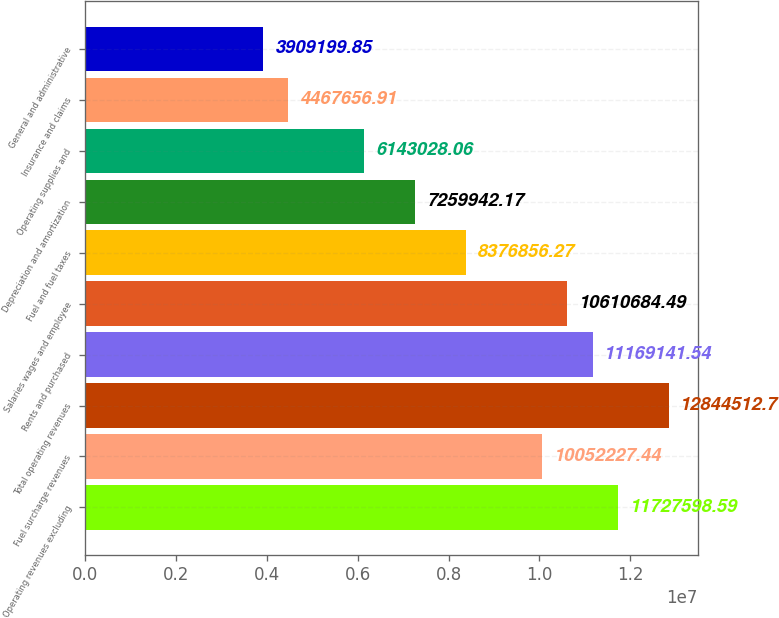Convert chart. <chart><loc_0><loc_0><loc_500><loc_500><bar_chart><fcel>Operating revenues excluding<fcel>Fuel surcharge revenues<fcel>Total operating revenues<fcel>Rents and purchased<fcel>Salaries wages and employee<fcel>Fuel and fuel taxes<fcel>Depreciation and amortization<fcel>Operating supplies and<fcel>Insurance and claims<fcel>General and administrative<nl><fcel>1.17276e+07<fcel>1.00522e+07<fcel>1.28445e+07<fcel>1.11691e+07<fcel>1.06107e+07<fcel>8.37686e+06<fcel>7.25994e+06<fcel>6.14303e+06<fcel>4.46766e+06<fcel>3.9092e+06<nl></chart> 